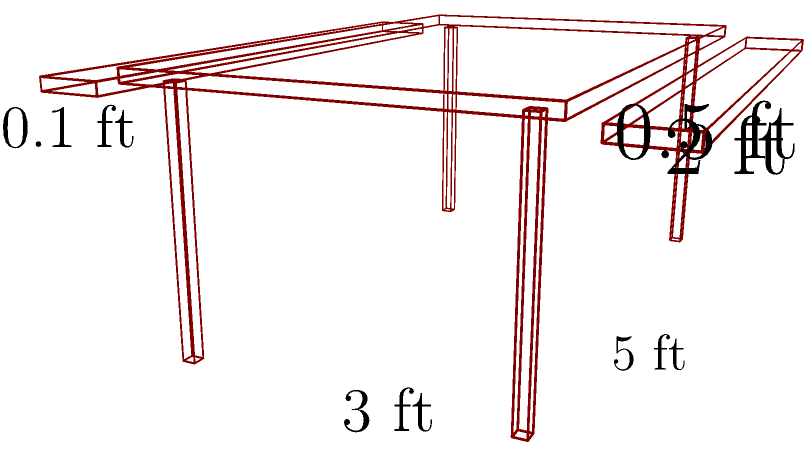You're planning to build a custom outdoor table with attached benches for your next backyard barbecue in Austin. The rectangular table top measures 5 ft long, 3 ft wide, and 0.1 ft thick. Two benches, each 5 ft long, 0.5 ft wide, and 0.1 ft thick, are attached to the long sides of the table. What is the total surface area of the table and benches combined in square feet? Let's break this down step-by-step:

1) First, calculate the surface area of the table top:
   - Top and bottom: $2 \times (5 \text{ ft} \times 3 \text{ ft}) = 30 \text{ sq ft}$
   - Sides: $2 \times (5 \text{ ft} \times 0.1 \text{ ft}) + 2 \times (3 \text{ ft} \times 0.1 \text{ ft}) = 1.6 \text{ sq ft}$
   Total for table top: $30 + 1.6 = 31.6 \text{ sq ft}$

2) Now, calculate the surface area of each bench:
   - Top and bottom: $2 \times (5 \text{ ft} \times 0.5 \text{ ft}) = 5 \text{ sq ft}$
   - Sides: $2 \times (5 \text{ ft} \times 0.1 \text{ ft}) + 2 \times (0.5 \text{ ft} \times 0.1 \text{ ft}) = 1.1 \text{ sq ft}$
   Total for one bench: $5 + 1.1 = 6.1 \text{ sq ft}$

3) There are two benches, so the total surface area for both benches is:
   $6.1 \text{ sq ft} \times 2 = 12.2 \text{ sq ft}$

4) The total surface area is the sum of the table top and both benches:
   $31.6 \text{ sq ft} + 12.2 \text{ sq ft} = 43.8 \text{ sq ft}$
Answer: $43.8 \text{ sq ft}$ 